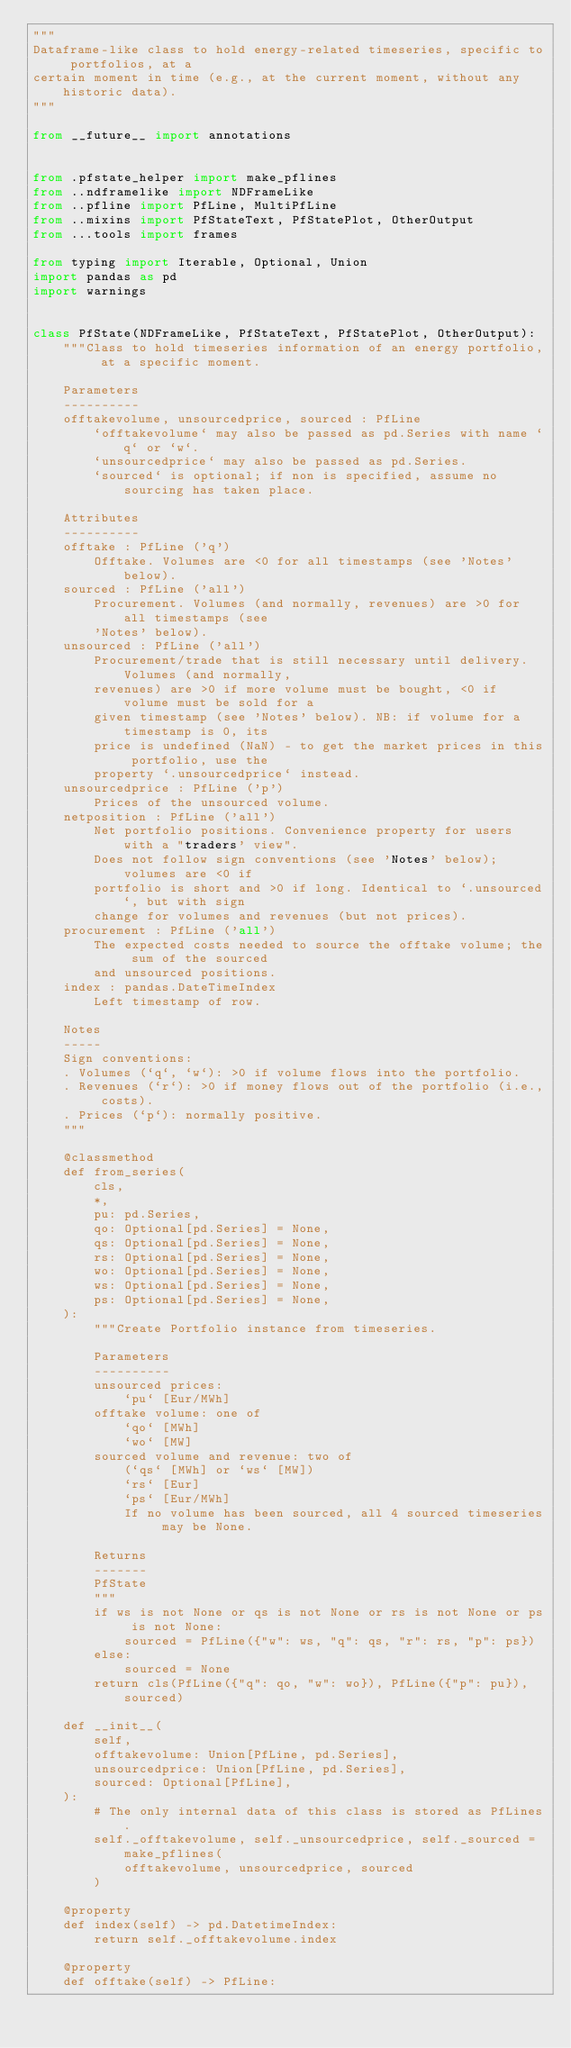Convert code to text. <code><loc_0><loc_0><loc_500><loc_500><_Python_>"""
Dataframe-like class to hold energy-related timeseries, specific to portfolios, at a
certain moment in time (e.g., at the current moment, without any historic data).
"""

from __future__ import annotations


from .pfstate_helper import make_pflines
from ..ndframelike import NDFrameLike
from ..pfline import PfLine, MultiPfLine
from ..mixins import PfStateText, PfStatePlot, OtherOutput
from ...tools import frames

from typing import Iterable, Optional, Union
import pandas as pd
import warnings


class PfState(NDFrameLike, PfStateText, PfStatePlot, OtherOutput):
    """Class to hold timeseries information of an energy portfolio, at a specific moment.

    Parameters
    ----------
    offtakevolume, unsourcedprice, sourced : PfLine
        `offtakevolume` may also be passed as pd.Series with name `q` or `w`.
        `unsourcedprice` may also be passed as pd.Series.
        `sourced` is optional; if non is specified, assume no sourcing has taken place.

    Attributes
    ----------
    offtake : PfLine ('q')
        Offtake. Volumes are <0 for all timestamps (see 'Notes' below).
    sourced : PfLine ('all')
        Procurement. Volumes (and normally, revenues) are >0 for all timestamps (see
        'Notes' below).
    unsourced : PfLine ('all')
        Procurement/trade that is still necessary until delivery. Volumes (and normally,
        revenues) are >0 if more volume must be bought, <0 if volume must be sold for a
        given timestamp (see 'Notes' below). NB: if volume for a timestamp is 0, its
        price is undefined (NaN) - to get the market prices in this portfolio, use the
        property `.unsourcedprice` instead.
    unsourcedprice : PfLine ('p')
        Prices of the unsourced volume.
    netposition : PfLine ('all')
        Net portfolio positions. Convenience property for users with a "traders' view".
        Does not follow sign conventions (see 'Notes' below); volumes are <0 if
        portfolio is short and >0 if long. Identical to `.unsourced`, but with sign
        change for volumes and revenues (but not prices).
    procurement : PfLine ('all')
        The expected costs needed to source the offtake volume; the sum of the sourced
        and unsourced positions.
    index : pandas.DateTimeIndex
        Left timestamp of row.

    Notes
    -----
    Sign conventions:
    . Volumes (`q`, `w`): >0 if volume flows into the portfolio.
    . Revenues (`r`): >0 if money flows out of the portfolio (i.e., costs).
    . Prices (`p`): normally positive.
    """

    @classmethod
    def from_series(
        cls,
        *,
        pu: pd.Series,
        qo: Optional[pd.Series] = None,
        qs: Optional[pd.Series] = None,
        rs: Optional[pd.Series] = None,
        wo: Optional[pd.Series] = None,
        ws: Optional[pd.Series] = None,
        ps: Optional[pd.Series] = None,
    ):
        """Create Portfolio instance from timeseries.

        Parameters
        ----------
        unsourced prices:
            `pu` [Eur/MWh]
        offtake volume: one of
            `qo` [MWh]
            `wo` [MW]
        sourced volume and revenue: two of
            (`qs` [MWh] or `ws` [MW])
            `rs` [Eur]
            `ps` [Eur/MWh]
            If no volume has been sourced, all 4 sourced timeseries may be None.

        Returns
        -------
        PfState
        """
        if ws is not None or qs is not None or rs is not None or ps is not None:
            sourced = PfLine({"w": ws, "q": qs, "r": rs, "p": ps})
        else:
            sourced = None
        return cls(PfLine({"q": qo, "w": wo}), PfLine({"p": pu}), sourced)

    def __init__(
        self,
        offtakevolume: Union[PfLine, pd.Series],
        unsourcedprice: Union[PfLine, pd.Series],
        sourced: Optional[PfLine],
    ):
        # The only internal data of this class is stored as PfLines.
        self._offtakevolume, self._unsourcedprice, self._sourced = make_pflines(
            offtakevolume, unsourcedprice, sourced
        )

    @property
    def index(self) -> pd.DatetimeIndex:
        return self._offtakevolume.index

    @property
    def offtake(self) -> PfLine:</code> 